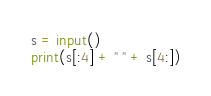Convert code to text. <code><loc_0><loc_0><loc_500><loc_500><_Python_>s = input()
print(s[:4] + " " + s[4:])
</code> 